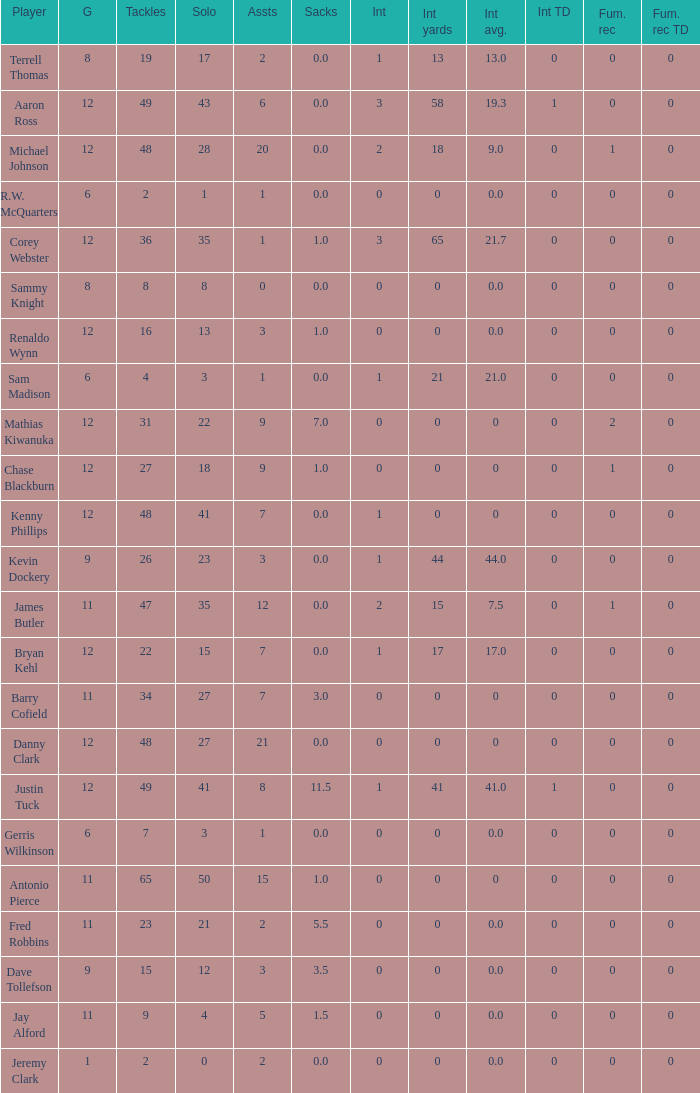Name the most tackles for 3.5 sacks 15.0. 